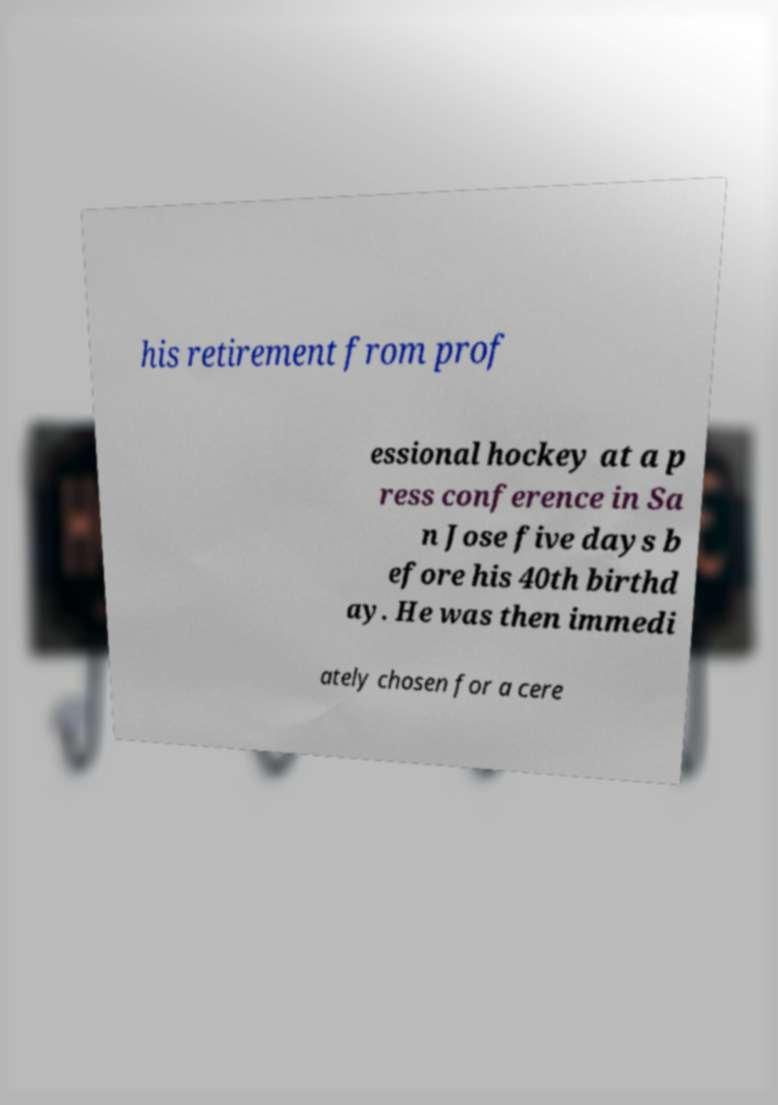Can you accurately transcribe the text from the provided image for me? his retirement from prof essional hockey at a p ress conference in Sa n Jose five days b efore his 40th birthd ay. He was then immedi ately chosen for a cere 